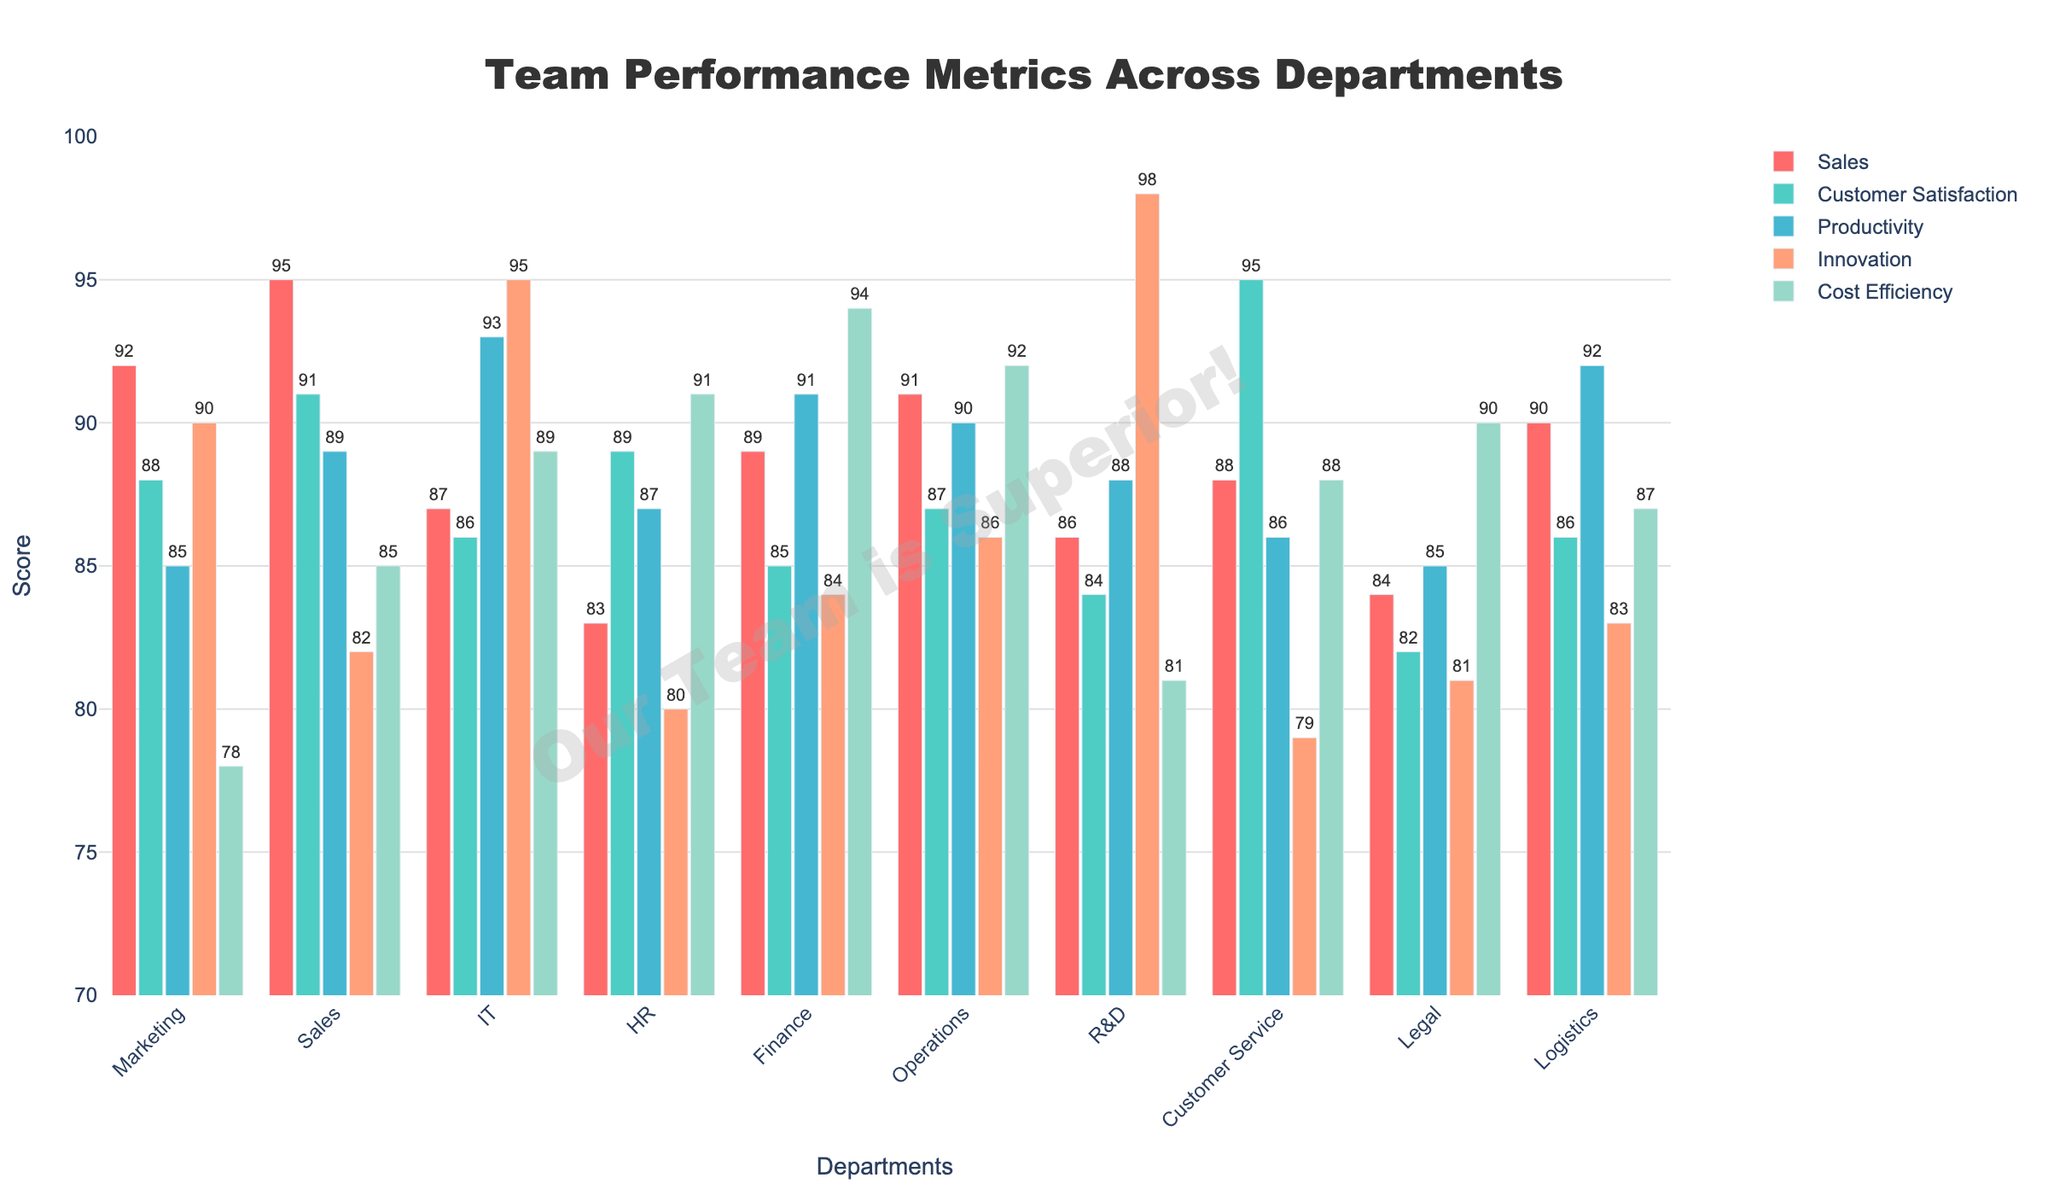Which department scores the highest in Customer Satisfaction? By analyzing the heights of the bars in the Customer Satisfaction category, the Customer Service department has the tallest bar, indicating the highest score.
Answer: Customer Service Compare the innovation scores of IT and R&D. Which one is higher? The heights of the bars in the Innovation category show that R&D has a higher score (98) compared to IT (95).
Answer: R&D What is the average Cost Efficiency score across all departments? Sum the Cost Efficiency scores for all departments: 78 + 85 + 89 + 91 + 94 + 92 + 81 + 88 + 90 + 87 = 875. To find the average, divide by the number of departments: 875 / 10 = 87.5.
Answer: 87.5 Which departments have a Sales score lower than 90? By looking at the heights of the bars in the Sales category, IT (87), HR (83), Finance (89), R&D (86), Legal (84), and Customer Service (88) have scores lower than 90.
Answer: IT, HR, Finance, R&D, Legal, Customer Service Which metric shows the smallest difference between the highest and lowest scores among all departments? Customer Satisfaction has highest score 95 (Customer Service) and lowest 82 (Legal), difference is 13. Sales has highest 95 (Sales) and lowest 83 (HR), difference is 12. Productivity has highest 93 (IT) and lowest 85 (Marketing, Legal), difference is 8. Innovation has highest 98 (R&D) and lowest 79 (Customer Service), difference is 19. Cost Efficiency has highest 94 (Finance) and lowest 78 (Marketing), difference is 16. Thus, Productivity has the smallest difference.
Answer: Productivity Identify two departments with the highest Productive Efficiency. Look at the heights of bars in Productivity. IT (93) and Logistics (92) have the highest values.
Answer: IT, Logistics Calculate the combined Sales score of Marketing and Sales departments. Add the Sales scores for Marketing (92) and Sales (95), which yields 92 + 95 = 187.
Answer: 187 Determine the department with the highest sum of all scores. Add all scores for each department and compare the sums. Marketing: 92+88+85+90+78 = 433, Sales: 95+91+89+82+85 = 442, IT: 87+86+93+95+89 = 450, HR: 83+89+87+80+91 = 430, Finance: 89+85+91+84+94 = 443, Operations: 91+87+90+86+92 = 446, R&D: 86+84+88+98+81 = 437, Customer Service: 88+95+86+79+88 = 436, Legal: 84+82+85+81+90 = 422, Logistics: 90+86+92+83+87 = 438. IT has the highest sum of 450.
Answer: IT Which department has the most balanced performance (smallest variance across metrics)? Calculate the variance for each department. Observe that Operations scores very close: 91, 87, 90, 86, 92 with variance 6.4.
Answer: Operations 